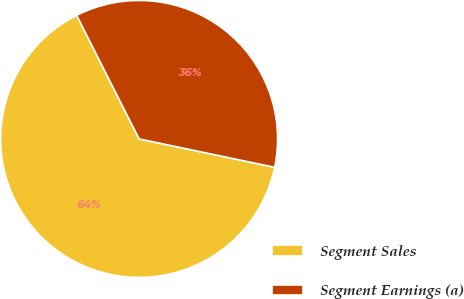<chart> <loc_0><loc_0><loc_500><loc_500><pie_chart><fcel>Segment Sales<fcel>Segment Earnings (a)<nl><fcel>64.27%<fcel>35.73%<nl></chart> 